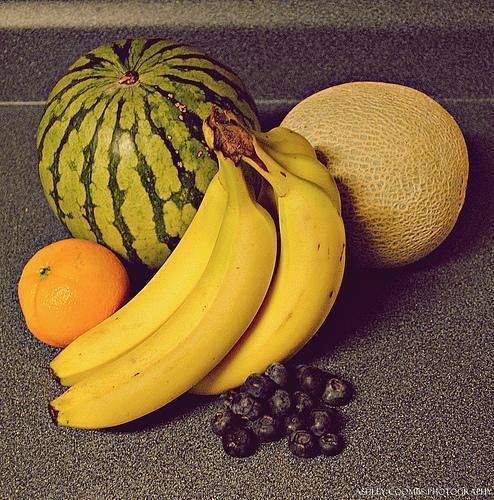How many bananas are there?
Give a very brief answer. 5. How many watermelons are on the counter?
Give a very brief answer. 1. 